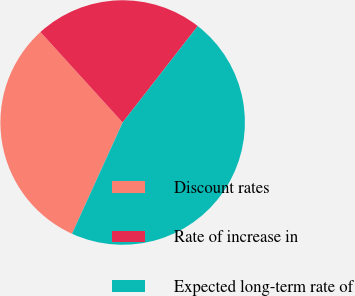<chart> <loc_0><loc_0><loc_500><loc_500><pie_chart><fcel>Discount rates<fcel>Rate of increase in<fcel>Expected long-term rate of<nl><fcel>31.47%<fcel>22.27%<fcel>46.26%<nl></chart> 